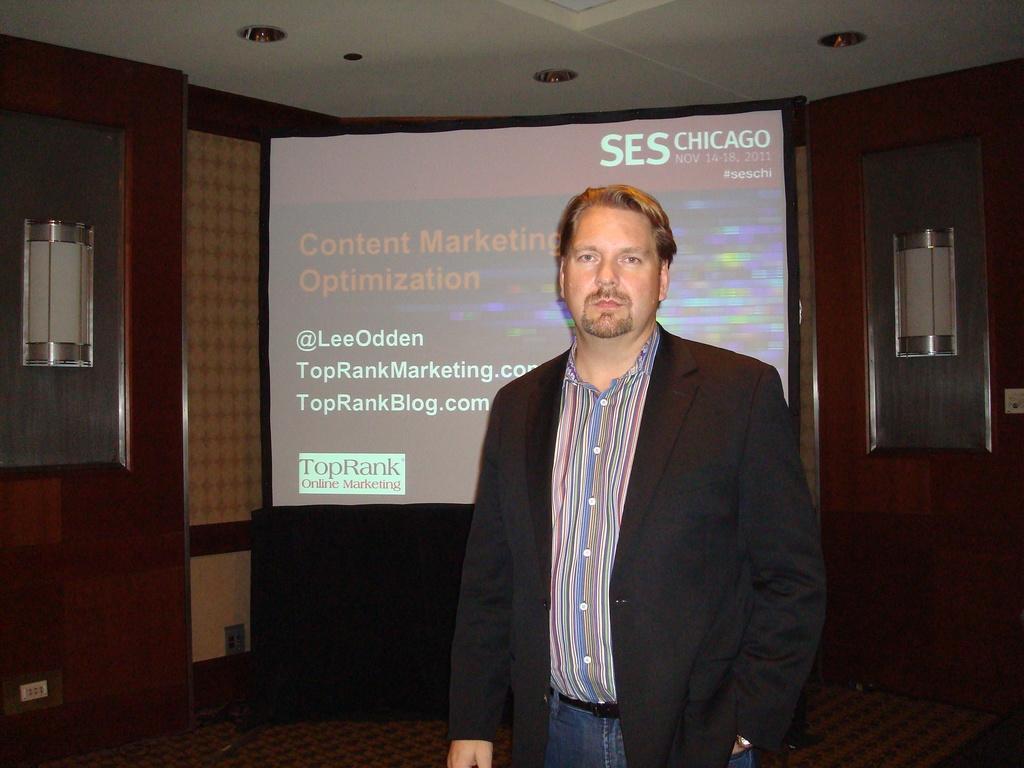Describe this image in one or two sentences. In this image we can see a person, behind to him there is a screen with some text on it, also we can see the wall, ceiling, and lights. 